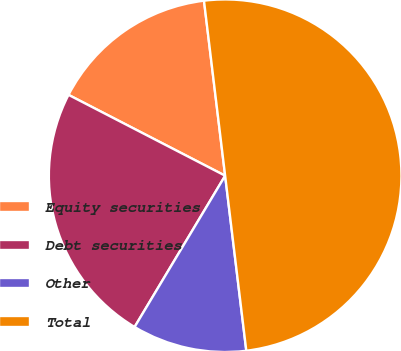Convert chart. <chart><loc_0><loc_0><loc_500><loc_500><pie_chart><fcel>Equity securities<fcel>Debt securities<fcel>Other<fcel>Total<nl><fcel>15.5%<fcel>24.0%<fcel>10.5%<fcel>50.0%<nl></chart> 